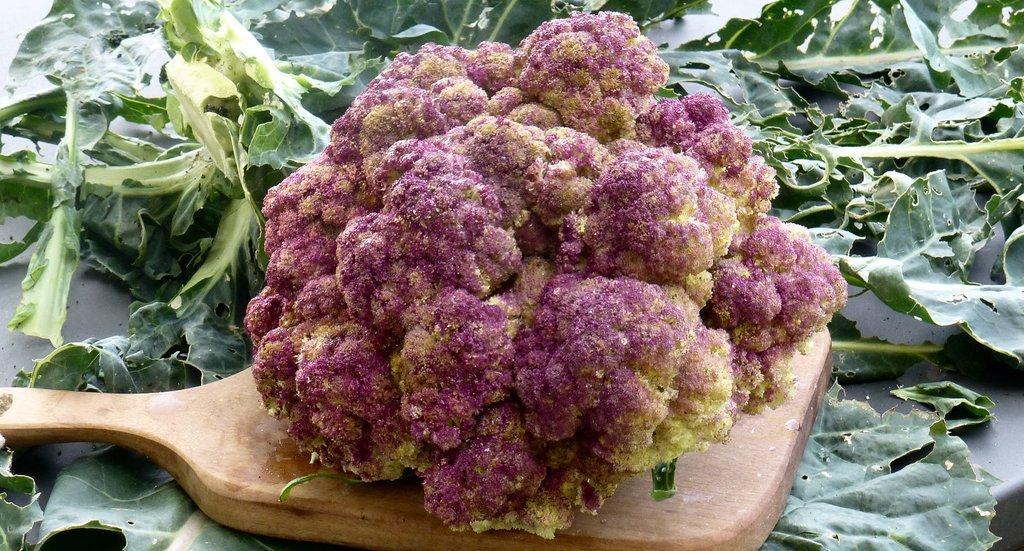Please provide a concise description of this image. In this picture there are leaves. In the foreground it looks like a cauliflower on the wooden object. 